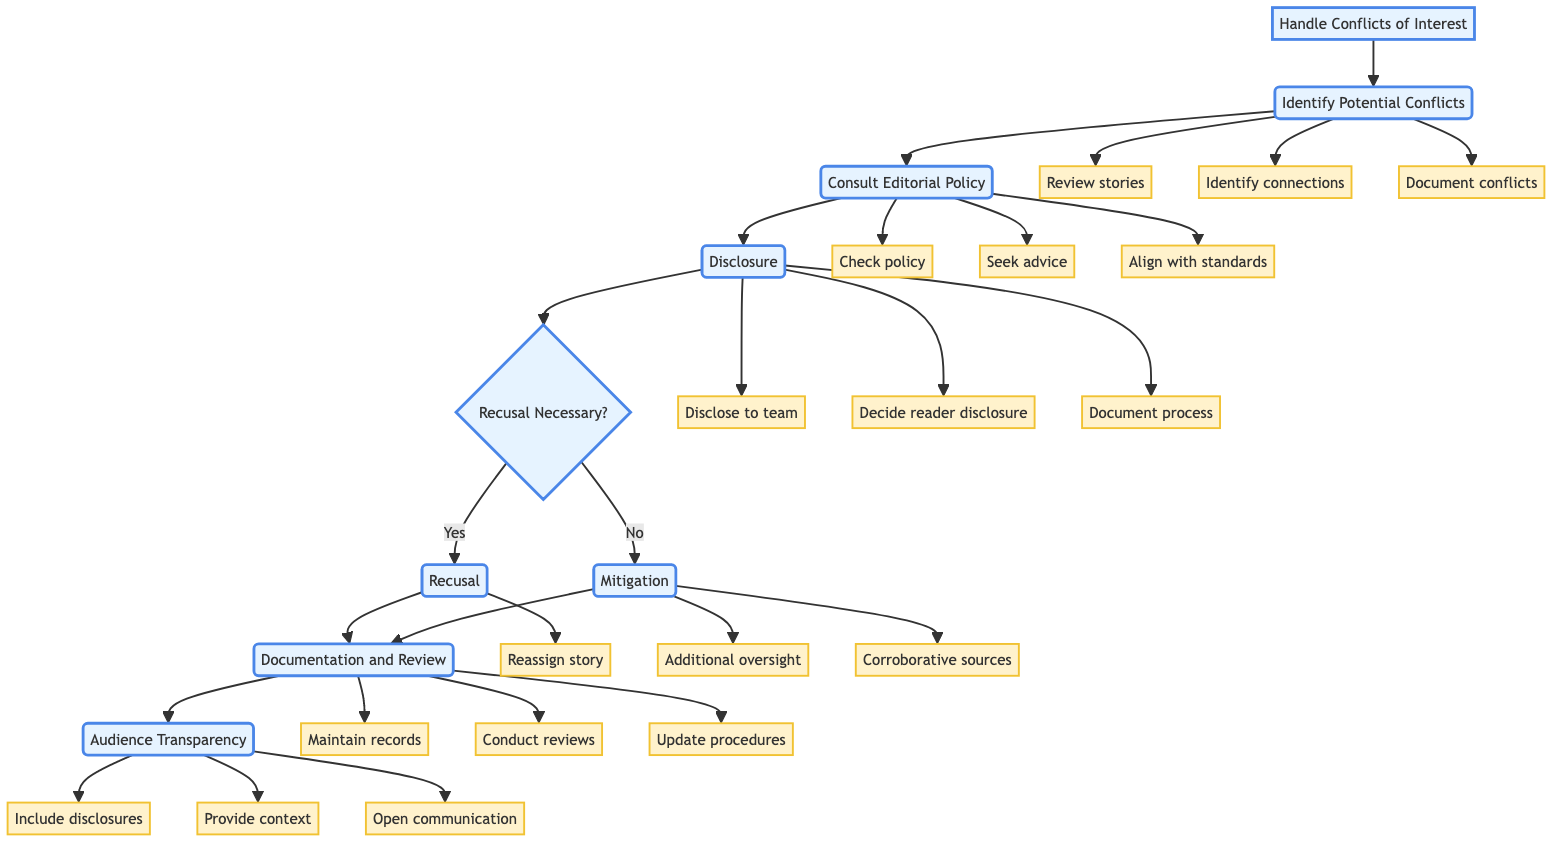What is the first stage in the flowchart? The first stage in the flowchart is "Identify Potential Conflicts." This is indicated as the initial node connected to the "Handle Conflicts of Interest" node.
Answer: Identify Potential Conflicts How many total actions are listed under the "Consult Editorial Policy" stage? There are three actions listed under the "Consult Editorial Policy" stage: "Refer to the publication's conflict of interest policy," "Seek advice from the editorial board or ethics committee," and "Ensure alignment with industry standards." These can be counted directly from the actions connected to this stage.
Answer: 3 What is the decision point in the flowchart? The decision point in the flowchart is labeled as "Recusal Necessary?" This node branches into two paths based on whether recusal is necessary or not.
Answer: Recusal Necessary? What happens if recusal is decided necessary? If recusal is deemed necessary, the next action is to "Reassign the story to another journalist." This can be traced through the flowchart from the decision point to the respective node.
Answer: Reassign the story to another journalist What must be documented during the Disclosure stage? During the Disclosure stage, it is essential to "Document the disclosure process and decisions made." This is specified as one of the actions listed under this stage.
Answer: Document the disclosure process and decisions made Identify one strategy to mitigate a conflict. One strategy to mitigate a conflict is "Additional oversight." This action is part of the options listed if recusal is not necessary.
Answer: Additional oversight What stage involves maintaining records? The stage that involves maintaining records is "Documentation and Review." This is clearly indicated as the node following either the recusal or mitigation paths.
Answer: Documentation and Review What is the last action in the flowchart? The last action in the flowchart is "Open communication." This action is part of the "Audience Transparency" stage, which follows the documentation process.
Answer: Open communication 